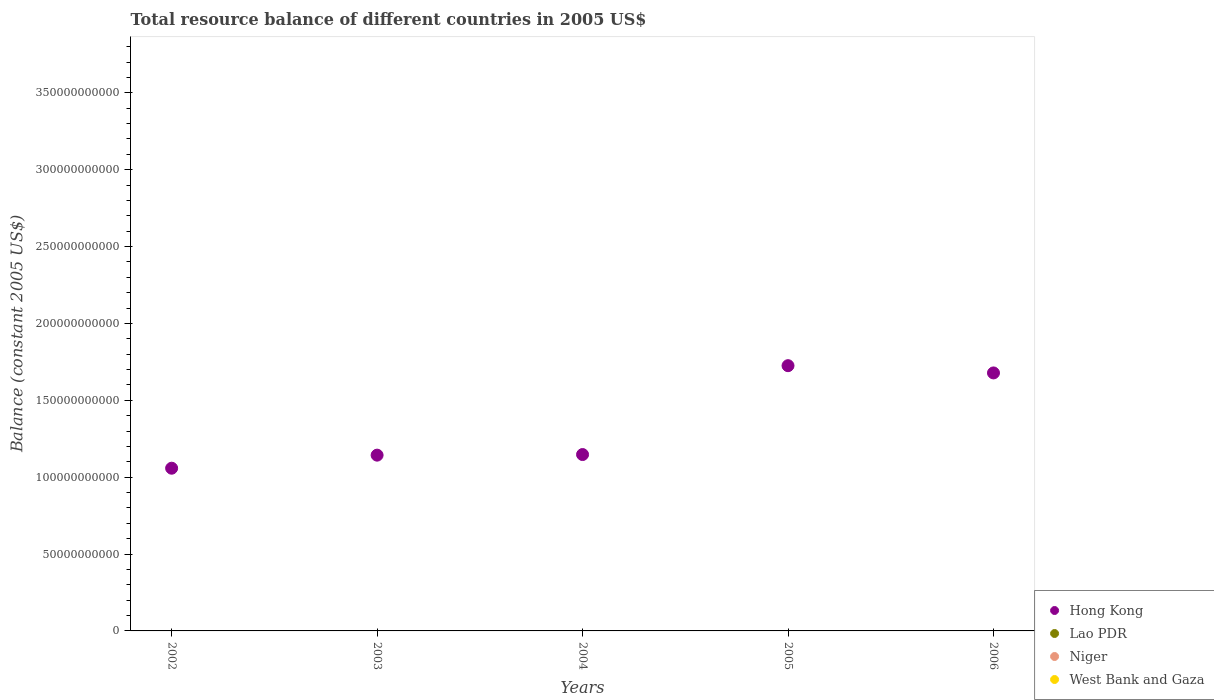How many different coloured dotlines are there?
Offer a very short reply. 1. What is the total resource balance in Hong Kong in 2005?
Make the answer very short. 1.73e+11. Across all years, what is the minimum total resource balance in Hong Kong?
Your response must be concise. 1.06e+11. What is the total total resource balance in Hong Kong in the graph?
Provide a short and direct response. 6.75e+11. What is the difference between the total resource balance in Hong Kong in 2003 and that in 2005?
Make the answer very short. -5.82e+1. What is the difference between the total resource balance in Niger in 2003 and the total resource balance in Lao PDR in 2005?
Your answer should be very brief. 0. What is the average total resource balance in Lao PDR per year?
Make the answer very short. 0. In how many years, is the total resource balance in Lao PDR greater than 320000000000 US$?
Offer a very short reply. 0. What is the ratio of the total resource balance in Hong Kong in 2002 to that in 2003?
Offer a terse response. 0.93. What is the difference between the highest and the second highest total resource balance in Hong Kong?
Your answer should be very brief. 4.72e+09. What is the difference between the highest and the lowest total resource balance in Hong Kong?
Provide a short and direct response. 6.67e+1. In how many years, is the total resource balance in Hong Kong greater than the average total resource balance in Hong Kong taken over all years?
Ensure brevity in your answer.  2. Does the total resource balance in Hong Kong monotonically increase over the years?
Provide a short and direct response. No. Is the total resource balance in Niger strictly less than the total resource balance in Lao PDR over the years?
Offer a terse response. No. How many dotlines are there?
Your response must be concise. 1. How many years are there in the graph?
Provide a short and direct response. 5. Are the values on the major ticks of Y-axis written in scientific E-notation?
Your response must be concise. No. Does the graph contain any zero values?
Provide a succinct answer. Yes. Does the graph contain grids?
Provide a short and direct response. No. Where does the legend appear in the graph?
Offer a very short reply. Bottom right. How many legend labels are there?
Ensure brevity in your answer.  4. What is the title of the graph?
Your response must be concise. Total resource balance of different countries in 2005 US$. What is the label or title of the Y-axis?
Your response must be concise. Balance (constant 2005 US$). What is the Balance (constant 2005 US$) of Hong Kong in 2002?
Make the answer very short. 1.06e+11. What is the Balance (constant 2005 US$) in Niger in 2002?
Your answer should be very brief. 0. What is the Balance (constant 2005 US$) of Hong Kong in 2003?
Keep it short and to the point. 1.14e+11. What is the Balance (constant 2005 US$) in Lao PDR in 2003?
Offer a terse response. 0. What is the Balance (constant 2005 US$) of Niger in 2003?
Give a very brief answer. 0. What is the Balance (constant 2005 US$) of Hong Kong in 2004?
Keep it short and to the point. 1.15e+11. What is the Balance (constant 2005 US$) of Niger in 2004?
Provide a short and direct response. 0. What is the Balance (constant 2005 US$) of West Bank and Gaza in 2004?
Provide a short and direct response. 0. What is the Balance (constant 2005 US$) of Hong Kong in 2005?
Keep it short and to the point. 1.73e+11. What is the Balance (constant 2005 US$) of Lao PDR in 2005?
Provide a short and direct response. 0. What is the Balance (constant 2005 US$) of Niger in 2005?
Provide a short and direct response. 0. What is the Balance (constant 2005 US$) in West Bank and Gaza in 2005?
Ensure brevity in your answer.  0. What is the Balance (constant 2005 US$) in Hong Kong in 2006?
Offer a terse response. 1.68e+11. What is the Balance (constant 2005 US$) in Lao PDR in 2006?
Provide a succinct answer. 0. Across all years, what is the maximum Balance (constant 2005 US$) of Hong Kong?
Provide a short and direct response. 1.73e+11. Across all years, what is the minimum Balance (constant 2005 US$) in Hong Kong?
Your response must be concise. 1.06e+11. What is the total Balance (constant 2005 US$) of Hong Kong in the graph?
Your answer should be compact. 6.75e+11. What is the total Balance (constant 2005 US$) in Lao PDR in the graph?
Keep it short and to the point. 0. What is the total Balance (constant 2005 US$) in Niger in the graph?
Your response must be concise. 0. What is the total Balance (constant 2005 US$) of West Bank and Gaza in the graph?
Provide a succinct answer. 0. What is the difference between the Balance (constant 2005 US$) in Hong Kong in 2002 and that in 2003?
Keep it short and to the point. -8.50e+09. What is the difference between the Balance (constant 2005 US$) in Hong Kong in 2002 and that in 2004?
Offer a very short reply. -8.89e+09. What is the difference between the Balance (constant 2005 US$) in Hong Kong in 2002 and that in 2005?
Your answer should be compact. -6.67e+1. What is the difference between the Balance (constant 2005 US$) in Hong Kong in 2002 and that in 2006?
Your answer should be very brief. -6.20e+1. What is the difference between the Balance (constant 2005 US$) of Hong Kong in 2003 and that in 2004?
Give a very brief answer. -3.93e+08. What is the difference between the Balance (constant 2005 US$) of Hong Kong in 2003 and that in 2005?
Your answer should be very brief. -5.82e+1. What is the difference between the Balance (constant 2005 US$) of Hong Kong in 2003 and that in 2006?
Provide a short and direct response. -5.35e+1. What is the difference between the Balance (constant 2005 US$) in Hong Kong in 2004 and that in 2005?
Your response must be concise. -5.78e+1. What is the difference between the Balance (constant 2005 US$) in Hong Kong in 2004 and that in 2006?
Offer a terse response. -5.31e+1. What is the difference between the Balance (constant 2005 US$) of Hong Kong in 2005 and that in 2006?
Ensure brevity in your answer.  4.72e+09. What is the average Balance (constant 2005 US$) in Hong Kong per year?
Your answer should be very brief. 1.35e+11. What is the average Balance (constant 2005 US$) of Lao PDR per year?
Provide a succinct answer. 0. What is the average Balance (constant 2005 US$) of Niger per year?
Your answer should be compact. 0. What is the average Balance (constant 2005 US$) in West Bank and Gaza per year?
Offer a terse response. 0. What is the ratio of the Balance (constant 2005 US$) in Hong Kong in 2002 to that in 2003?
Give a very brief answer. 0.93. What is the ratio of the Balance (constant 2005 US$) of Hong Kong in 2002 to that in 2004?
Give a very brief answer. 0.92. What is the ratio of the Balance (constant 2005 US$) of Hong Kong in 2002 to that in 2005?
Keep it short and to the point. 0.61. What is the ratio of the Balance (constant 2005 US$) in Hong Kong in 2002 to that in 2006?
Ensure brevity in your answer.  0.63. What is the ratio of the Balance (constant 2005 US$) of Hong Kong in 2003 to that in 2004?
Your answer should be compact. 1. What is the ratio of the Balance (constant 2005 US$) in Hong Kong in 2003 to that in 2005?
Ensure brevity in your answer.  0.66. What is the ratio of the Balance (constant 2005 US$) of Hong Kong in 2003 to that in 2006?
Your answer should be very brief. 0.68. What is the ratio of the Balance (constant 2005 US$) in Hong Kong in 2004 to that in 2005?
Your response must be concise. 0.67. What is the ratio of the Balance (constant 2005 US$) of Hong Kong in 2004 to that in 2006?
Give a very brief answer. 0.68. What is the ratio of the Balance (constant 2005 US$) of Hong Kong in 2005 to that in 2006?
Offer a very short reply. 1.03. What is the difference between the highest and the second highest Balance (constant 2005 US$) in Hong Kong?
Keep it short and to the point. 4.72e+09. What is the difference between the highest and the lowest Balance (constant 2005 US$) in Hong Kong?
Make the answer very short. 6.67e+1. 